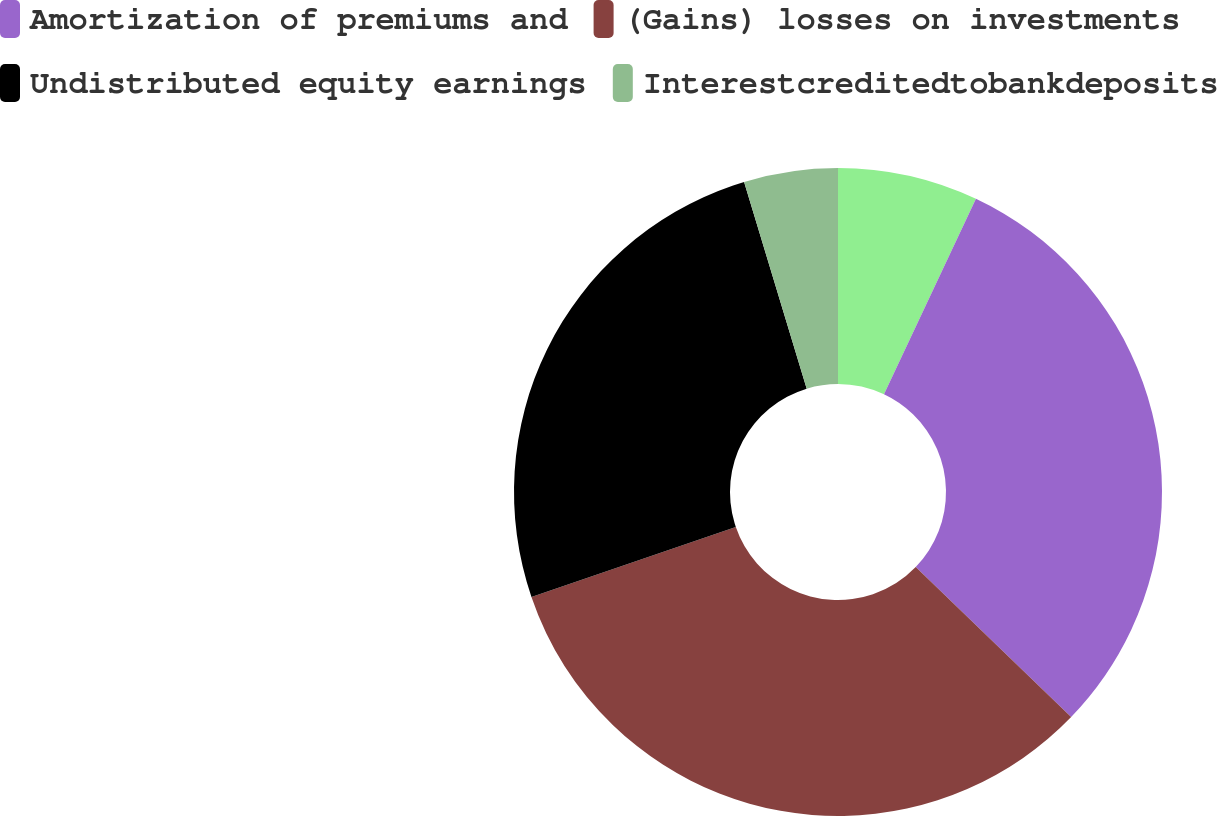Convert chart to OTSL. <chart><loc_0><loc_0><loc_500><loc_500><pie_chart><ecel><fcel>Amortization of premiums and<fcel>(Gains) losses on investments<fcel>Undistributed equity earnings<fcel>Interestcreditedtobankdeposits<nl><fcel>7.0%<fcel>30.22%<fcel>32.54%<fcel>25.57%<fcel>4.68%<nl></chart> 